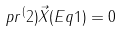Convert formula to latex. <formula><loc_0><loc_0><loc_500><loc_500>p r { ^ { ( } 2 ) } \vec { X } ( E q 1 ) = 0</formula> 